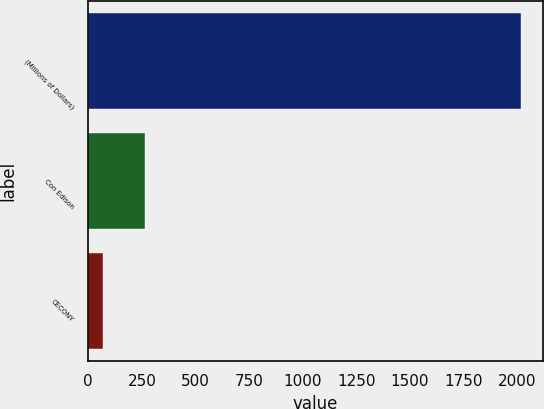Convert chart to OTSL. <chart><loc_0><loc_0><loc_500><loc_500><bar_chart><fcel>(Millions of Dollars)<fcel>Con Edison<fcel>CECONY<nl><fcel>2019<fcel>264.9<fcel>70<nl></chart> 